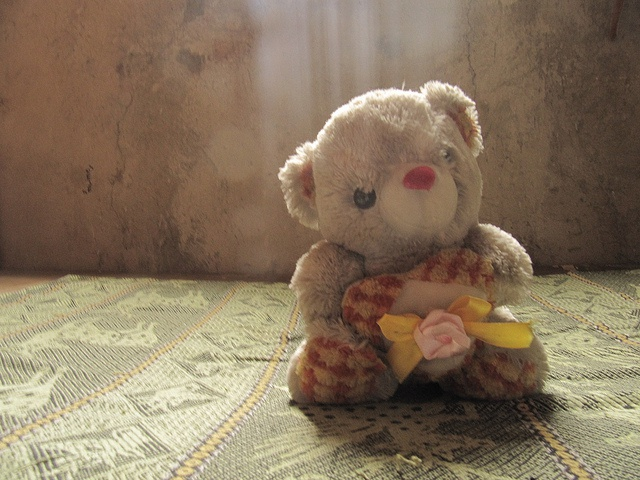Describe the objects in this image and their specific colors. I can see a teddy bear in brown, gray, and maroon tones in this image. 